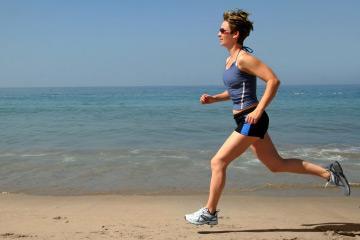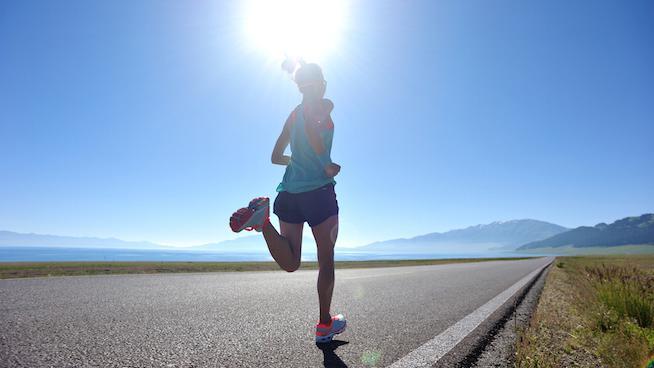The first image is the image on the left, the second image is the image on the right. Analyze the images presented: Is the assertion "One person is running leftward in front of a body of water." valid? Answer yes or no. Yes. The first image is the image on the left, the second image is the image on the right. Evaluate the accuracy of this statement regarding the images: "One of the runners is running on a road and the other is running by a body of water.". Is it true? Answer yes or no. Yes. 